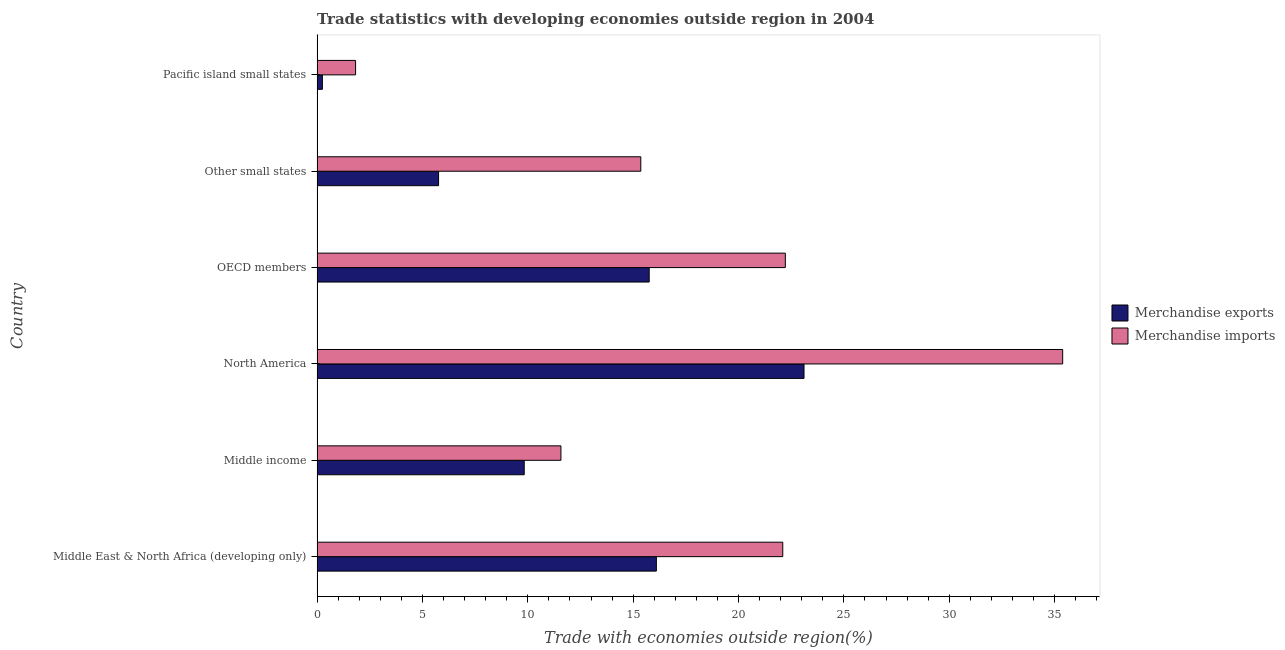How many different coloured bars are there?
Your answer should be very brief. 2. How many groups of bars are there?
Keep it short and to the point. 6. Are the number of bars on each tick of the Y-axis equal?
Offer a very short reply. Yes. How many bars are there on the 1st tick from the bottom?
Offer a terse response. 2. What is the label of the 6th group of bars from the top?
Your answer should be very brief. Middle East & North Africa (developing only). In how many cases, is the number of bars for a given country not equal to the number of legend labels?
Your response must be concise. 0. What is the merchandise imports in North America?
Provide a short and direct response. 35.38. Across all countries, what is the maximum merchandise imports?
Offer a very short reply. 35.38. Across all countries, what is the minimum merchandise imports?
Provide a short and direct response. 1.83. In which country was the merchandise imports minimum?
Offer a terse response. Pacific island small states. What is the total merchandise exports in the graph?
Offer a terse response. 70.82. What is the difference between the merchandise exports in Middle East & North Africa (developing only) and that in Pacific island small states?
Ensure brevity in your answer.  15.85. What is the difference between the merchandise exports in North America and the merchandise imports in Middle East & North Africa (developing only)?
Ensure brevity in your answer.  1.01. What is the average merchandise imports per country?
Provide a short and direct response. 18.08. What is the difference between the merchandise exports and merchandise imports in Middle income?
Give a very brief answer. -1.74. In how many countries, is the merchandise imports greater than 6 %?
Your response must be concise. 5. What is the ratio of the merchandise exports in Middle East & North Africa (developing only) to that in Middle income?
Give a very brief answer. 1.64. Is the difference between the merchandise imports in OECD members and Other small states greater than the difference between the merchandise exports in OECD members and Other small states?
Give a very brief answer. No. What is the difference between the highest and the second highest merchandise exports?
Your response must be concise. 7. What is the difference between the highest and the lowest merchandise exports?
Keep it short and to the point. 22.85. How many bars are there?
Your answer should be very brief. 12. Are all the bars in the graph horizontal?
Keep it short and to the point. Yes. Are the values on the major ticks of X-axis written in scientific E-notation?
Your response must be concise. No. Does the graph contain grids?
Your answer should be compact. No. Where does the legend appear in the graph?
Ensure brevity in your answer.  Center right. How many legend labels are there?
Offer a very short reply. 2. How are the legend labels stacked?
Give a very brief answer. Vertical. What is the title of the graph?
Ensure brevity in your answer.  Trade statistics with developing economies outside region in 2004. What is the label or title of the X-axis?
Make the answer very short. Trade with economies outside region(%). What is the label or title of the Y-axis?
Give a very brief answer. Country. What is the Trade with economies outside region(%) in Merchandise exports in Middle East & North Africa (developing only)?
Make the answer very short. 16.1. What is the Trade with economies outside region(%) in Merchandise imports in Middle East & North Africa (developing only)?
Make the answer very short. 22.1. What is the Trade with economies outside region(%) in Merchandise exports in Middle income?
Keep it short and to the point. 9.83. What is the Trade with economies outside region(%) of Merchandise imports in Middle income?
Keep it short and to the point. 11.57. What is the Trade with economies outside region(%) in Merchandise exports in North America?
Your answer should be compact. 23.11. What is the Trade with economies outside region(%) of Merchandise imports in North America?
Ensure brevity in your answer.  35.38. What is the Trade with economies outside region(%) in Merchandise exports in OECD members?
Give a very brief answer. 15.76. What is the Trade with economies outside region(%) in Merchandise imports in OECD members?
Offer a terse response. 22.22. What is the Trade with economies outside region(%) of Merchandise exports in Other small states?
Make the answer very short. 5.77. What is the Trade with economies outside region(%) in Merchandise imports in Other small states?
Keep it short and to the point. 15.36. What is the Trade with economies outside region(%) of Merchandise exports in Pacific island small states?
Provide a short and direct response. 0.25. What is the Trade with economies outside region(%) of Merchandise imports in Pacific island small states?
Offer a very short reply. 1.83. Across all countries, what is the maximum Trade with economies outside region(%) of Merchandise exports?
Keep it short and to the point. 23.11. Across all countries, what is the maximum Trade with economies outside region(%) in Merchandise imports?
Ensure brevity in your answer.  35.38. Across all countries, what is the minimum Trade with economies outside region(%) of Merchandise exports?
Your answer should be very brief. 0.25. Across all countries, what is the minimum Trade with economies outside region(%) in Merchandise imports?
Keep it short and to the point. 1.83. What is the total Trade with economies outside region(%) of Merchandise exports in the graph?
Offer a very short reply. 70.82. What is the total Trade with economies outside region(%) of Merchandise imports in the graph?
Provide a short and direct response. 108.47. What is the difference between the Trade with economies outside region(%) of Merchandise exports in Middle East & North Africa (developing only) and that in Middle income?
Make the answer very short. 6.27. What is the difference between the Trade with economies outside region(%) of Merchandise imports in Middle East & North Africa (developing only) and that in Middle income?
Your answer should be very brief. 10.53. What is the difference between the Trade with economies outside region(%) of Merchandise exports in Middle East & North Africa (developing only) and that in North America?
Your response must be concise. -7.01. What is the difference between the Trade with economies outside region(%) of Merchandise imports in Middle East & North Africa (developing only) and that in North America?
Your response must be concise. -13.28. What is the difference between the Trade with economies outside region(%) of Merchandise exports in Middle East & North Africa (developing only) and that in OECD members?
Provide a short and direct response. 0.34. What is the difference between the Trade with economies outside region(%) of Merchandise imports in Middle East & North Africa (developing only) and that in OECD members?
Your answer should be very brief. -0.12. What is the difference between the Trade with economies outside region(%) in Merchandise exports in Middle East & North Africa (developing only) and that in Other small states?
Offer a terse response. 10.34. What is the difference between the Trade with economies outside region(%) of Merchandise imports in Middle East & North Africa (developing only) and that in Other small states?
Provide a succinct answer. 6.74. What is the difference between the Trade with economies outside region(%) of Merchandise exports in Middle East & North Africa (developing only) and that in Pacific island small states?
Your answer should be very brief. 15.85. What is the difference between the Trade with economies outside region(%) in Merchandise imports in Middle East & North Africa (developing only) and that in Pacific island small states?
Give a very brief answer. 20.27. What is the difference between the Trade with economies outside region(%) of Merchandise exports in Middle income and that in North America?
Ensure brevity in your answer.  -13.28. What is the difference between the Trade with economies outside region(%) in Merchandise imports in Middle income and that in North America?
Your answer should be very brief. -23.81. What is the difference between the Trade with economies outside region(%) of Merchandise exports in Middle income and that in OECD members?
Your answer should be very brief. -5.93. What is the difference between the Trade with economies outside region(%) of Merchandise imports in Middle income and that in OECD members?
Ensure brevity in your answer.  -10.65. What is the difference between the Trade with economies outside region(%) in Merchandise exports in Middle income and that in Other small states?
Offer a terse response. 4.06. What is the difference between the Trade with economies outside region(%) in Merchandise imports in Middle income and that in Other small states?
Ensure brevity in your answer.  -3.79. What is the difference between the Trade with economies outside region(%) of Merchandise exports in Middle income and that in Pacific island small states?
Provide a succinct answer. 9.58. What is the difference between the Trade with economies outside region(%) of Merchandise imports in Middle income and that in Pacific island small states?
Offer a very short reply. 9.74. What is the difference between the Trade with economies outside region(%) in Merchandise exports in North America and that in OECD members?
Keep it short and to the point. 7.35. What is the difference between the Trade with economies outside region(%) in Merchandise imports in North America and that in OECD members?
Keep it short and to the point. 13.16. What is the difference between the Trade with economies outside region(%) of Merchandise exports in North America and that in Other small states?
Provide a short and direct response. 17.34. What is the difference between the Trade with economies outside region(%) in Merchandise imports in North America and that in Other small states?
Provide a short and direct response. 20.02. What is the difference between the Trade with economies outside region(%) of Merchandise exports in North America and that in Pacific island small states?
Your response must be concise. 22.85. What is the difference between the Trade with economies outside region(%) of Merchandise imports in North America and that in Pacific island small states?
Your answer should be very brief. 33.55. What is the difference between the Trade with economies outside region(%) in Merchandise exports in OECD members and that in Other small states?
Your answer should be very brief. 9.99. What is the difference between the Trade with economies outside region(%) of Merchandise imports in OECD members and that in Other small states?
Give a very brief answer. 6.86. What is the difference between the Trade with economies outside region(%) in Merchandise exports in OECD members and that in Pacific island small states?
Make the answer very short. 15.51. What is the difference between the Trade with economies outside region(%) of Merchandise imports in OECD members and that in Pacific island small states?
Make the answer very short. 20.39. What is the difference between the Trade with economies outside region(%) in Merchandise exports in Other small states and that in Pacific island small states?
Ensure brevity in your answer.  5.51. What is the difference between the Trade with economies outside region(%) of Merchandise imports in Other small states and that in Pacific island small states?
Provide a succinct answer. 13.53. What is the difference between the Trade with economies outside region(%) in Merchandise exports in Middle East & North Africa (developing only) and the Trade with economies outside region(%) in Merchandise imports in Middle income?
Provide a short and direct response. 4.53. What is the difference between the Trade with economies outside region(%) of Merchandise exports in Middle East & North Africa (developing only) and the Trade with economies outside region(%) of Merchandise imports in North America?
Your answer should be very brief. -19.28. What is the difference between the Trade with economies outside region(%) of Merchandise exports in Middle East & North Africa (developing only) and the Trade with economies outside region(%) of Merchandise imports in OECD members?
Offer a terse response. -6.12. What is the difference between the Trade with economies outside region(%) in Merchandise exports in Middle East & North Africa (developing only) and the Trade with economies outside region(%) in Merchandise imports in Other small states?
Keep it short and to the point. 0.74. What is the difference between the Trade with economies outside region(%) of Merchandise exports in Middle East & North Africa (developing only) and the Trade with economies outside region(%) of Merchandise imports in Pacific island small states?
Provide a short and direct response. 14.27. What is the difference between the Trade with economies outside region(%) of Merchandise exports in Middle income and the Trade with economies outside region(%) of Merchandise imports in North America?
Provide a succinct answer. -25.55. What is the difference between the Trade with economies outside region(%) in Merchandise exports in Middle income and the Trade with economies outside region(%) in Merchandise imports in OECD members?
Give a very brief answer. -12.39. What is the difference between the Trade with economies outside region(%) in Merchandise exports in Middle income and the Trade with economies outside region(%) in Merchandise imports in Other small states?
Make the answer very short. -5.53. What is the difference between the Trade with economies outside region(%) of Merchandise exports in Middle income and the Trade with economies outside region(%) of Merchandise imports in Pacific island small states?
Your answer should be very brief. 8. What is the difference between the Trade with economies outside region(%) in Merchandise exports in North America and the Trade with economies outside region(%) in Merchandise imports in OECD members?
Your response must be concise. 0.89. What is the difference between the Trade with economies outside region(%) of Merchandise exports in North America and the Trade with economies outside region(%) of Merchandise imports in Other small states?
Offer a very short reply. 7.74. What is the difference between the Trade with economies outside region(%) of Merchandise exports in North America and the Trade with economies outside region(%) of Merchandise imports in Pacific island small states?
Make the answer very short. 21.28. What is the difference between the Trade with economies outside region(%) in Merchandise exports in OECD members and the Trade with economies outside region(%) in Merchandise imports in Other small states?
Your answer should be compact. 0.4. What is the difference between the Trade with economies outside region(%) in Merchandise exports in OECD members and the Trade with economies outside region(%) in Merchandise imports in Pacific island small states?
Offer a terse response. 13.93. What is the difference between the Trade with economies outside region(%) of Merchandise exports in Other small states and the Trade with economies outside region(%) of Merchandise imports in Pacific island small states?
Offer a very short reply. 3.94. What is the average Trade with economies outside region(%) in Merchandise exports per country?
Your response must be concise. 11.8. What is the average Trade with economies outside region(%) of Merchandise imports per country?
Your answer should be very brief. 18.08. What is the difference between the Trade with economies outside region(%) of Merchandise exports and Trade with economies outside region(%) of Merchandise imports in Middle East & North Africa (developing only)?
Ensure brevity in your answer.  -6. What is the difference between the Trade with economies outside region(%) of Merchandise exports and Trade with economies outside region(%) of Merchandise imports in Middle income?
Offer a terse response. -1.74. What is the difference between the Trade with economies outside region(%) of Merchandise exports and Trade with economies outside region(%) of Merchandise imports in North America?
Offer a terse response. -12.27. What is the difference between the Trade with economies outside region(%) in Merchandise exports and Trade with economies outside region(%) in Merchandise imports in OECD members?
Keep it short and to the point. -6.46. What is the difference between the Trade with economies outside region(%) of Merchandise exports and Trade with economies outside region(%) of Merchandise imports in Other small states?
Offer a very short reply. -9.6. What is the difference between the Trade with economies outside region(%) of Merchandise exports and Trade with economies outside region(%) of Merchandise imports in Pacific island small states?
Make the answer very short. -1.58. What is the ratio of the Trade with economies outside region(%) of Merchandise exports in Middle East & North Africa (developing only) to that in Middle income?
Give a very brief answer. 1.64. What is the ratio of the Trade with economies outside region(%) of Merchandise imports in Middle East & North Africa (developing only) to that in Middle income?
Your answer should be compact. 1.91. What is the ratio of the Trade with economies outside region(%) of Merchandise exports in Middle East & North Africa (developing only) to that in North America?
Offer a very short reply. 0.7. What is the ratio of the Trade with economies outside region(%) in Merchandise imports in Middle East & North Africa (developing only) to that in North America?
Make the answer very short. 0.62. What is the ratio of the Trade with economies outside region(%) in Merchandise exports in Middle East & North Africa (developing only) to that in OECD members?
Offer a terse response. 1.02. What is the ratio of the Trade with economies outside region(%) in Merchandise imports in Middle East & North Africa (developing only) to that in OECD members?
Offer a very short reply. 0.99. What is the ratio of the Trade with economies outside region(%) in Merchandise exports in Middle East & North Africa (developing only) to that in Other small states?
Your response must be concise. 2.79. What is the ratio of the Trade with economies outside region(%) of Merchandise imports in Middle East & North Africa (developing only) to that in Other small states?
Offer a terse response. 1.44. What is the ratio of the Trade with economies outside region(%) of Merchandise exports in Middle East & North Africa (developing only) to that in Pacific island small states?
Offer a very short reply. 63.58. What is the ratio of the Trade with economies outside region(%) in Merchandise imports in Middle East & North Africa (developing only) to that in Pacific island small states?
Make the answer very short. 12.08. What is the ratio of the Trade with economies outside region(%) in Merchandise exports in Middle income to that in North America?
Give a very brief answer. 0.43. What is the ratio of the Trade with economies outside region(%) in Merchandise imports in Middle income to that in North America?
Your answer should be compact. 0.33. What is the ratio of the Trade with economies outside region(%) of Merchandise exports in Middle income to that in OECD members?
Keep it short and to the point. 0.62. What is the ratio of the Trade with economies outside region(%) in Merchandise imports in Middle income to that in OECD members?
Keep it short and to the point. 0.52. What is the ratio of the Trade with economies outside region(%) of Merchandise exports in Middle income to that in Other small states?
Your answer should be compact. 1.7. What is the ratio of the Trade with economies outside region(%) in Merchandise imports in Middle income to that in Other small states?
Make the answer very short. 0.75. What is the ratio of the Trade with economies outside region(%) of Merchandise exports in Middle income to that in Pacific island small states?
Provide a succinct answer. 38.81. What is the ratio of the Trade with economies outside region(%) in Merchandise imports in Middle income to that in Pacific island small states?
Keep it short and to the point. 6.33. What is the ratio of the Trade with economies outside region(%) of Merchandise exports in North America to that in OECD members?
Your response must be concise. 1.47. What is the ratio of the Trade with economies outside region(%) of Merchandise imports in North America to that in OECD members?
Your response must be concise. 1.59. What is the ratio of the Trade with economies outside region(%) in Merchandise exports in North America to that in Other small states?
Your response must be concise. 4.01. What is the ratio of the Trade with economies outside region(%) of Merchandise imports in North America to that in Other small states?
Ensure brevity in your answer.  2.3. What is the ratio of the Trade with economies outside region(%) in Merchandise exports in North America to that in Pacific island small states?
Your answer should be very brief. 91.24. What is the ratio of the Trade with economies outside region(%) in Merchandise imports in North America to that in Pacific island small states?
Ensure brevity in your answer.  19.35. What is the ratio of the Trade with economies outside region(%) in Merchandise exports in OECD members to that in Other small states?
Offer a terse response. 2.73. What is the ratio of the Trade with economies outside region(%) of Merchandise imports in OECD members to that in Other small states?
Make the answer very short. 1.45. What is the ratio of the Trade with economies outside region(%) in Merchandise exports in OECD members to that in Pacific island small states?
Your answer should be very brief. 62.23. What is the ratio of the Trade with economies outside region(%) of Merchandise imports in OECD members to that in Pacific island small states?
Keep it short and to the point. 12.15. What is the ratio of the Trade with economies outside region(%) of Merchandise exports in Other small states to that in Pacific island small states?
Make the answer very short. 22.77. What is the ratio of the Trade with economies outside region(%) in Merchandise imports in Other small states to that in Pacific island small states?
Make the answer very short. 8.4. What is the difference between the highest and the second highest Trade with economies outside region(%) of Merchandise exports?
Your answer should be compact. 7.01. What is the difference between the highest and the second highest Trade with economies outside region(%) of Merchandise imports?
Make the answer very short. 13.16. What is the difference between the highest and the lowest Trade with economies outside region(%) in Merchandise exports?
Offer a terse response. 22.85. What is the difference between the highest and the lowest Trade with economies outside region(%) of Merchandise imports?
Ensure brevity in your answer.  33.55. 